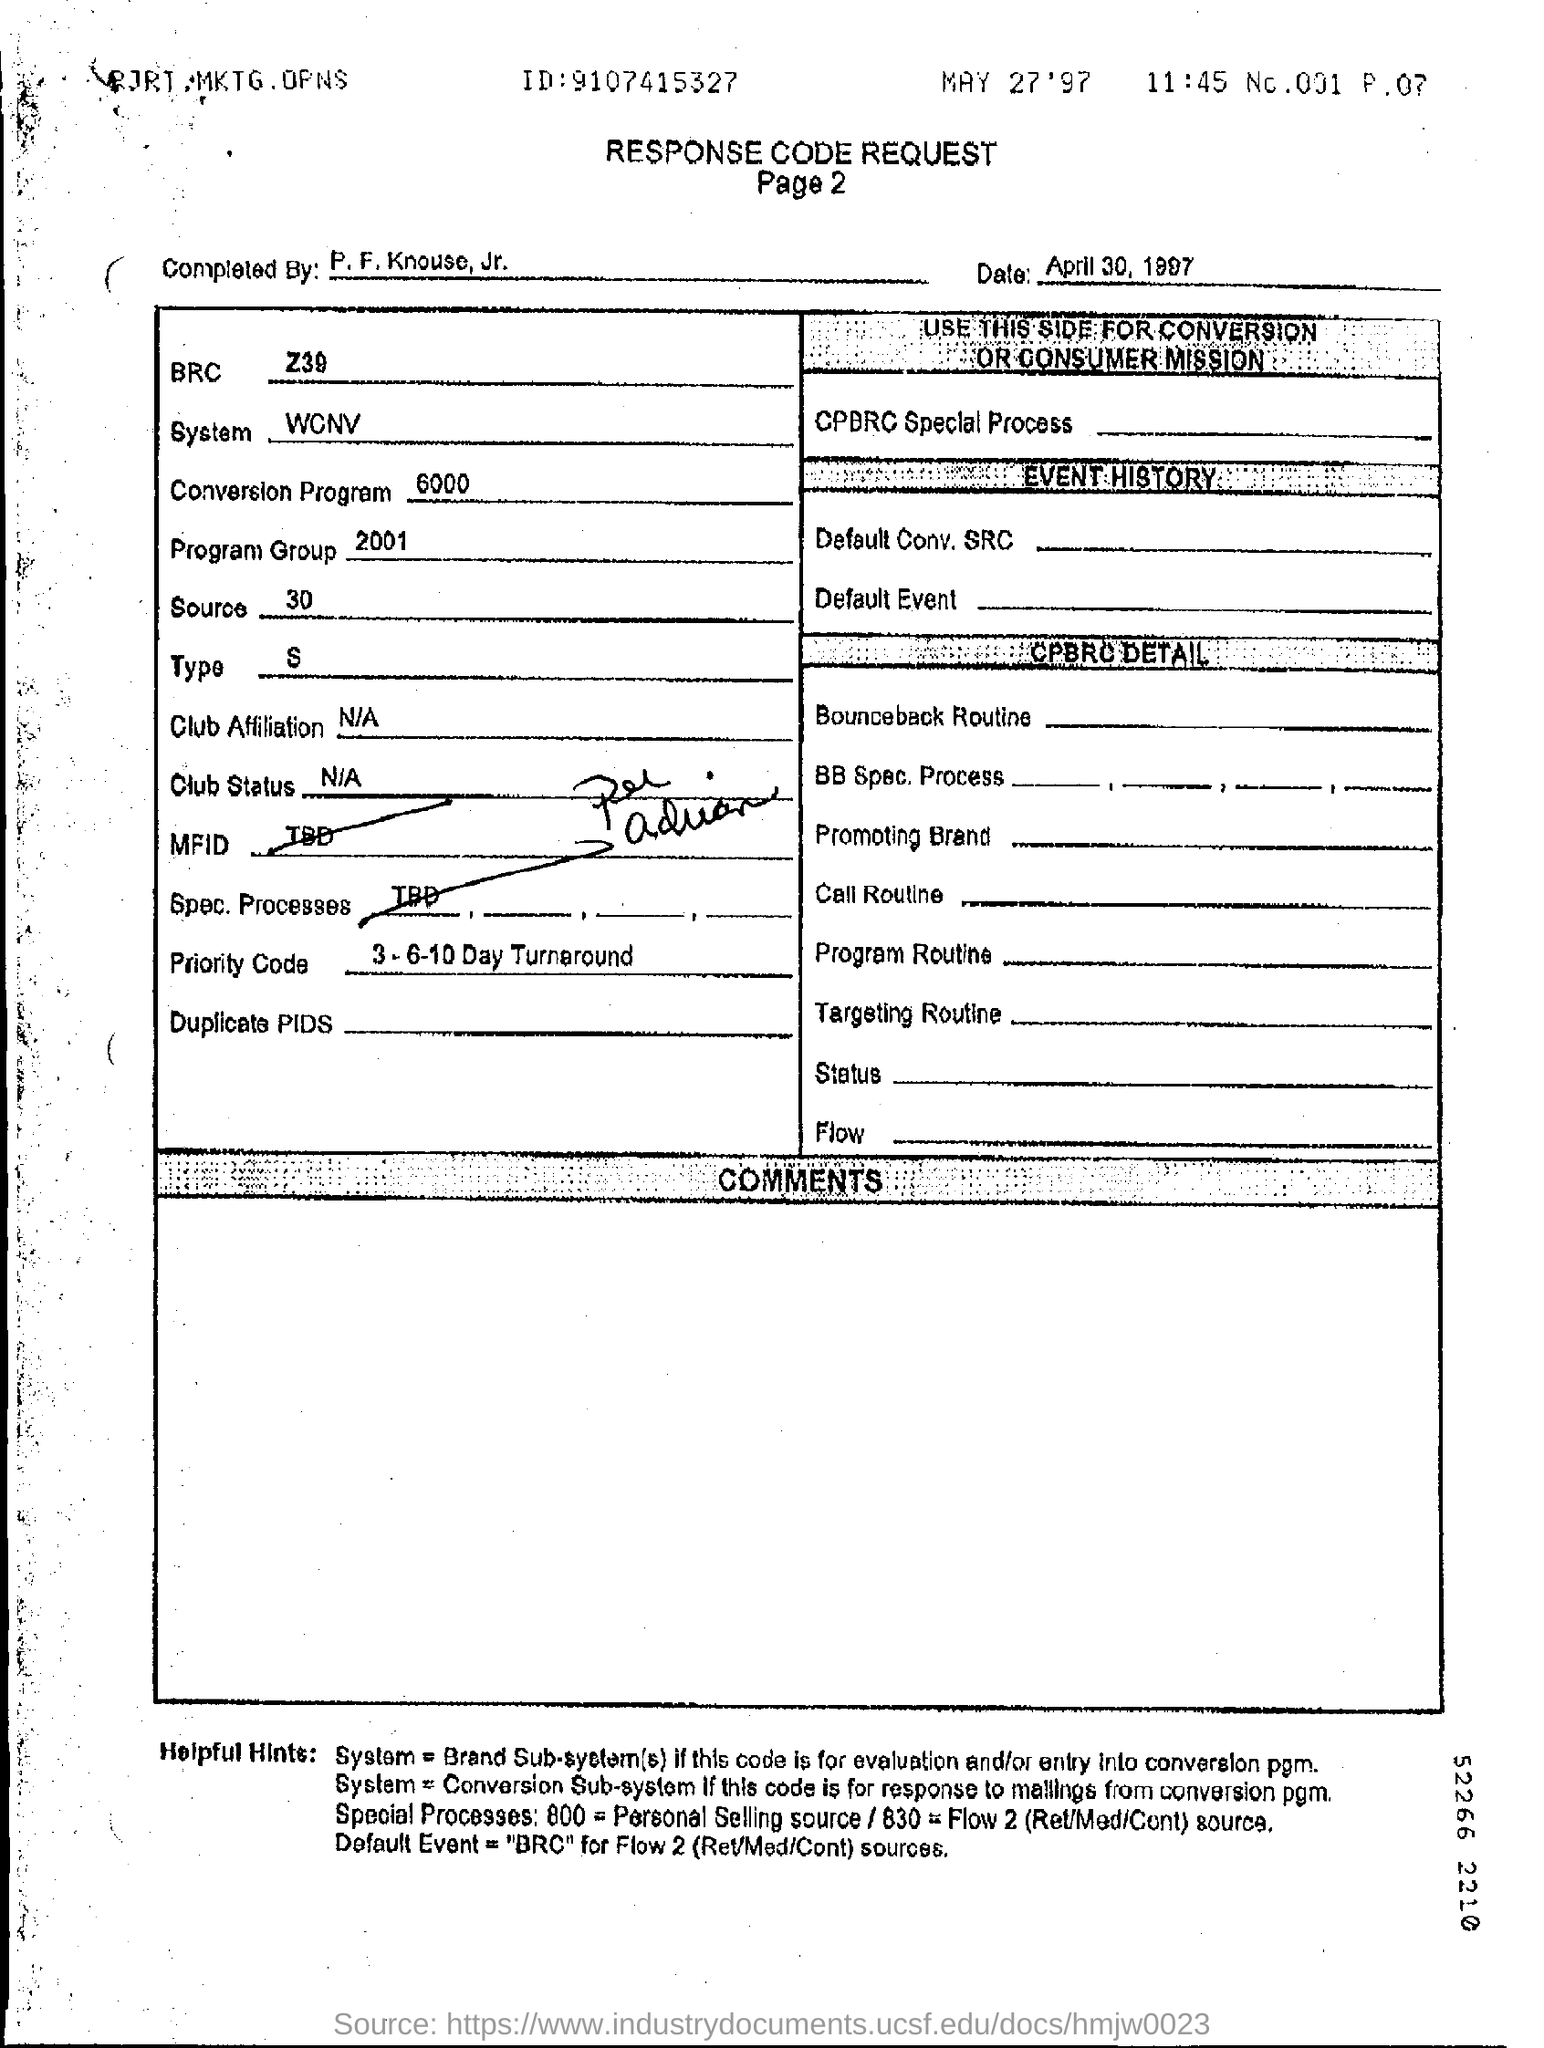Give some essential details in this illustration. The completion of the Response Code Request was performed by P. F. Knouse, Jr. The term 'BRC' refers to the 'Bibliographic Record' in the context of the 'Z39.50' standard. On April 30, 1997, the Response Code request was completed. 